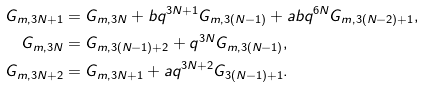Convert formula to latex. <formula><loc_0><loc_0><loc_500><loc_500>G _ { m , 3 N + 1 } & = G _ { m , 3 N } + b q ^ { 3 N + 1 } G _ { m , 3 ( N - 1 ) } + a b q ^ { 6 N } G _ { m , 3 ( N - 2 ) + 1 } , \\ G _ { m , 3 N } & = G _ { m , 3 ( N - 1 ) + 2 } + q ^ { 3 N } G _ { m , 3 ( N - 1 ) } , \\ G _ { m , 3 N + 2 } & = G _ { m , 3 N + 1 } + a q ^ { 3 N + 2 } G _ { 3 ( N - 1 ) + 1 } .</formula> 